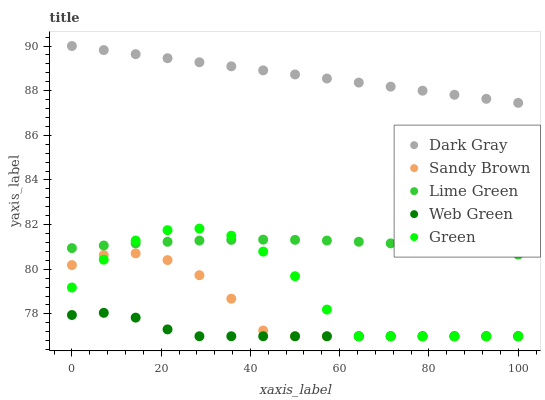Does Web Green have the minimum area under the curve?
Answer yes or no. Yes. Does Dark Gray have the maximum area under the curve?
Answer yes or no. Yes. Does Lime Green have the minimum area under the curve?
Answer yes or no. No. Does Lime Green have the maximum area under the curve?
Answer yes or no. No. Is Dark Gray the smoothest?
Answer yes or no. Yes. Is Green the roughest?
Answer yes or no. Yes. Is Lime Green the smoothest?
Answer yes or no. No. Is Lime Green the roughest?
Answer yes or no. No. Does Green have the lowest value?
Answer yes or no. Yes. Does Lime Green have the lowest value?
Answer yes or no. No. Does Dark Gray have the highest value?
Answer yes or no. Yes. Does Lime Green have the highest value?
Answer yes or no. No. Is Lime Green less than Dark Gray?
Answer yes or no. Yes. Is Lime Green greater than Sandy Brown?
Answer yes or no. Yes. Does Sandy Brown intersect Green?
Answer yes or no. Yes. Is Sandy Brown less than Green?
Answer yes or no. No. Is Sandy Brown greater than Green?
Answer yes or no. No. Does Lime Green intersect Dark Gray?
Answer yes or no. No. 